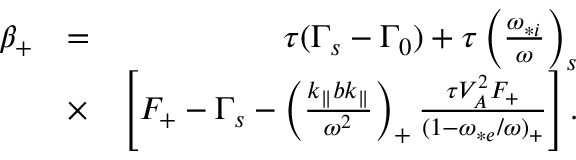Convert formula to latex. <formula><loc_0><loc_0><loc_500><loc_500>\begin{array} { r l r } { \beta _ { + } } & { = } & { \tau ( \Gamma _ { s } - \Gamma _ { 0 } ) + \tau \left ( \frac { \omega _ { * i } } { \omega } \right ) _ { s } } \\ & { \times } & { \left [ F _ { + } - \Gamma _ { s } - \left ( \frac { k _ { \| } b k _ { \| } } { \omega ^ { 2 } } \right ) _ { + } \frac { \tau V _ { A } ^ { 2 } F _ { + } } { ( 1 - \omega _ { * e } / \omega ) _ { + } } \right ] . } \end{array}</formula> 